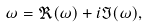Convert formula to latex. <formula><loc_0><loc_0><loc_500><loc_500>\omega = \Re ( \omega ) + i \Im ( \omega ) ,</formula> 